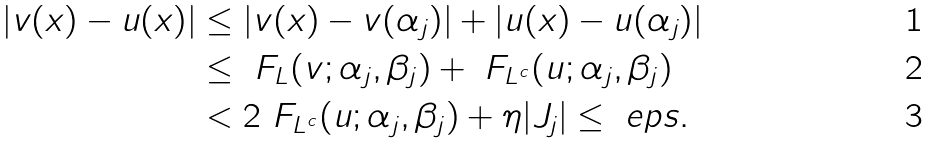Convert formula to latex. <formula><loc_0><loc_0><loc_500><loc_500>| v ( x ) - u ( x ) | & \leq | v ( x ) - v ( \alpha _ { j } ) | + | u ( x ) - u ( \alpha _ { j } ) | \\ & \leq \ F _ { L } ( v ; \alpha _ { j } , \beta _ { j } ) + \ F _ { L ^ { c } } ( u ; \alpha _ { j } , \beta _ { j } ) \\ & < 2 \ F _ { L ^ { c } } ( u ; \alpha _ { j } , \beta _ { j } ) + \eta | J _ { j } | \leq \ e p s .</formula> 